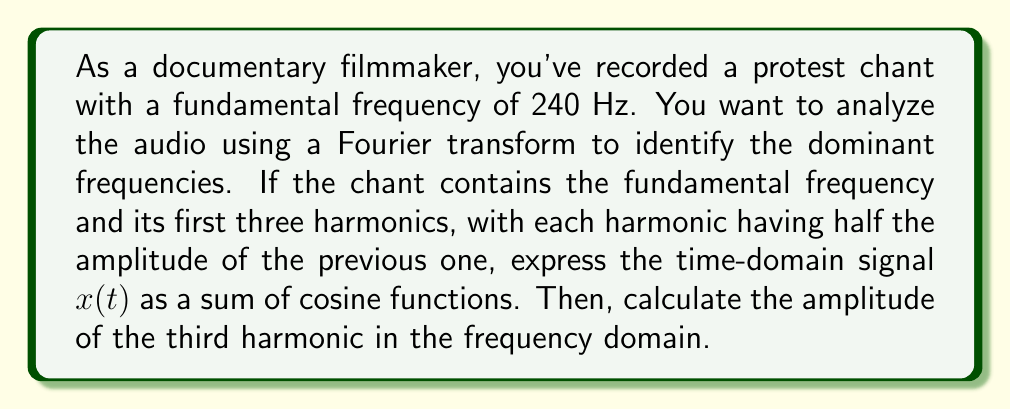Help me with this question. Let's approach this step-by-step:

1) The fundamental frequency is 240 Hz. The harmonics are integer multiples of this frequency:
   - 1st harmonic (fundamental): 240 Hz
   - 2nd harmonic: 480 Hz
   - 3rd harmonic: 720 Hz
   - 4th harmonic: 960 Hz

2) Let's assign an amplitude of 1 to the fundamental frequency. Each subsequent harmonic has half the amplitude of the previous one:
   - Fundamental: amplitude 1
   - 2nd harmonic: amplitude 1/2
   - 3rd harmonic: amplitude 1/4
   - 4th harmonic: amplitude 1/8

3) The time-domain signal $x(t)$ can be expressed as a sum of cosine functions:

   $$x(t) = \cos(2\pi \cdot 240t) + \frac{1}{2}\cos(2\pi \cdot 480t) + \frac{1}{4}\cos(2\pi \cdot 720t) + \frac{1}{8}\cos(2\pi \cdot 960t)$$

4) In the frequency domain, the Fourier transform will show peaks at these frequencies. The amplitude of each peak will be half of the time-domain amplitude because the Fourier transform distributes the energy between positive and negative frequencies.

5) Therefore, the amplitude of the third harmonic (720 Hz) in the frequency domain will be:

   $$\frac{1}{4} \cdot \frac{1}{2} = \frac{1}{8}$$
Answer: The amplitude of the third harmonic (720 Hz) in the frequency domain is $\frac{1}{8}$. 